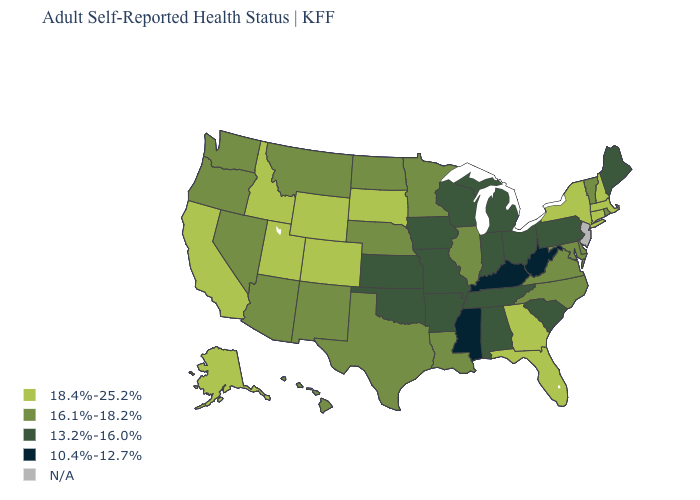Name the states that have a value in the range 18.4%-25.2%?
Answer briefly. Alaska, California, Colorado, Connecticut, Florida, Georgia, Idaho, Massachusetts, New Hampshire, New York, South Dakota, Utah, Wyoming. Name the states that have a value in the range N/A?
Keep it brief. New Jersey. Does the map have missing data?
Write a very short answer. Yes. What is the lowest value in the USA?
Keep it brief. 10.4%-12.7%. What is the value of Washington?
Quick response, please. 16.1%-18.2%. What is the highest value in the USA?
Keep it brief. 18.4%-25.2%. Name the states that have a value in the range 13.2%-16.0%?
Keep it brief. Alabama, Arkansas, Indiana, Iowa, Kansas, Maine, Michigan, Missouri, Ohio, Oklahoma, Pennsylvania, South Carolina, Tennessee, Wisconsin. Does the first symbol in the legend represent the smallest category?
Answer briefly. No. What is the value of North Dakota?
Keep it brief. 16.1%-18.2%. What is the lowest value in the MidWest?
Quick response, please. 13.2%-16.0%. Which states have the lowest value in the South?
Write a very short answer. Kentucky, Mississippi, West Virginia. Does New York have the highest value in the Northeast?
Keep it brief. Yes. 